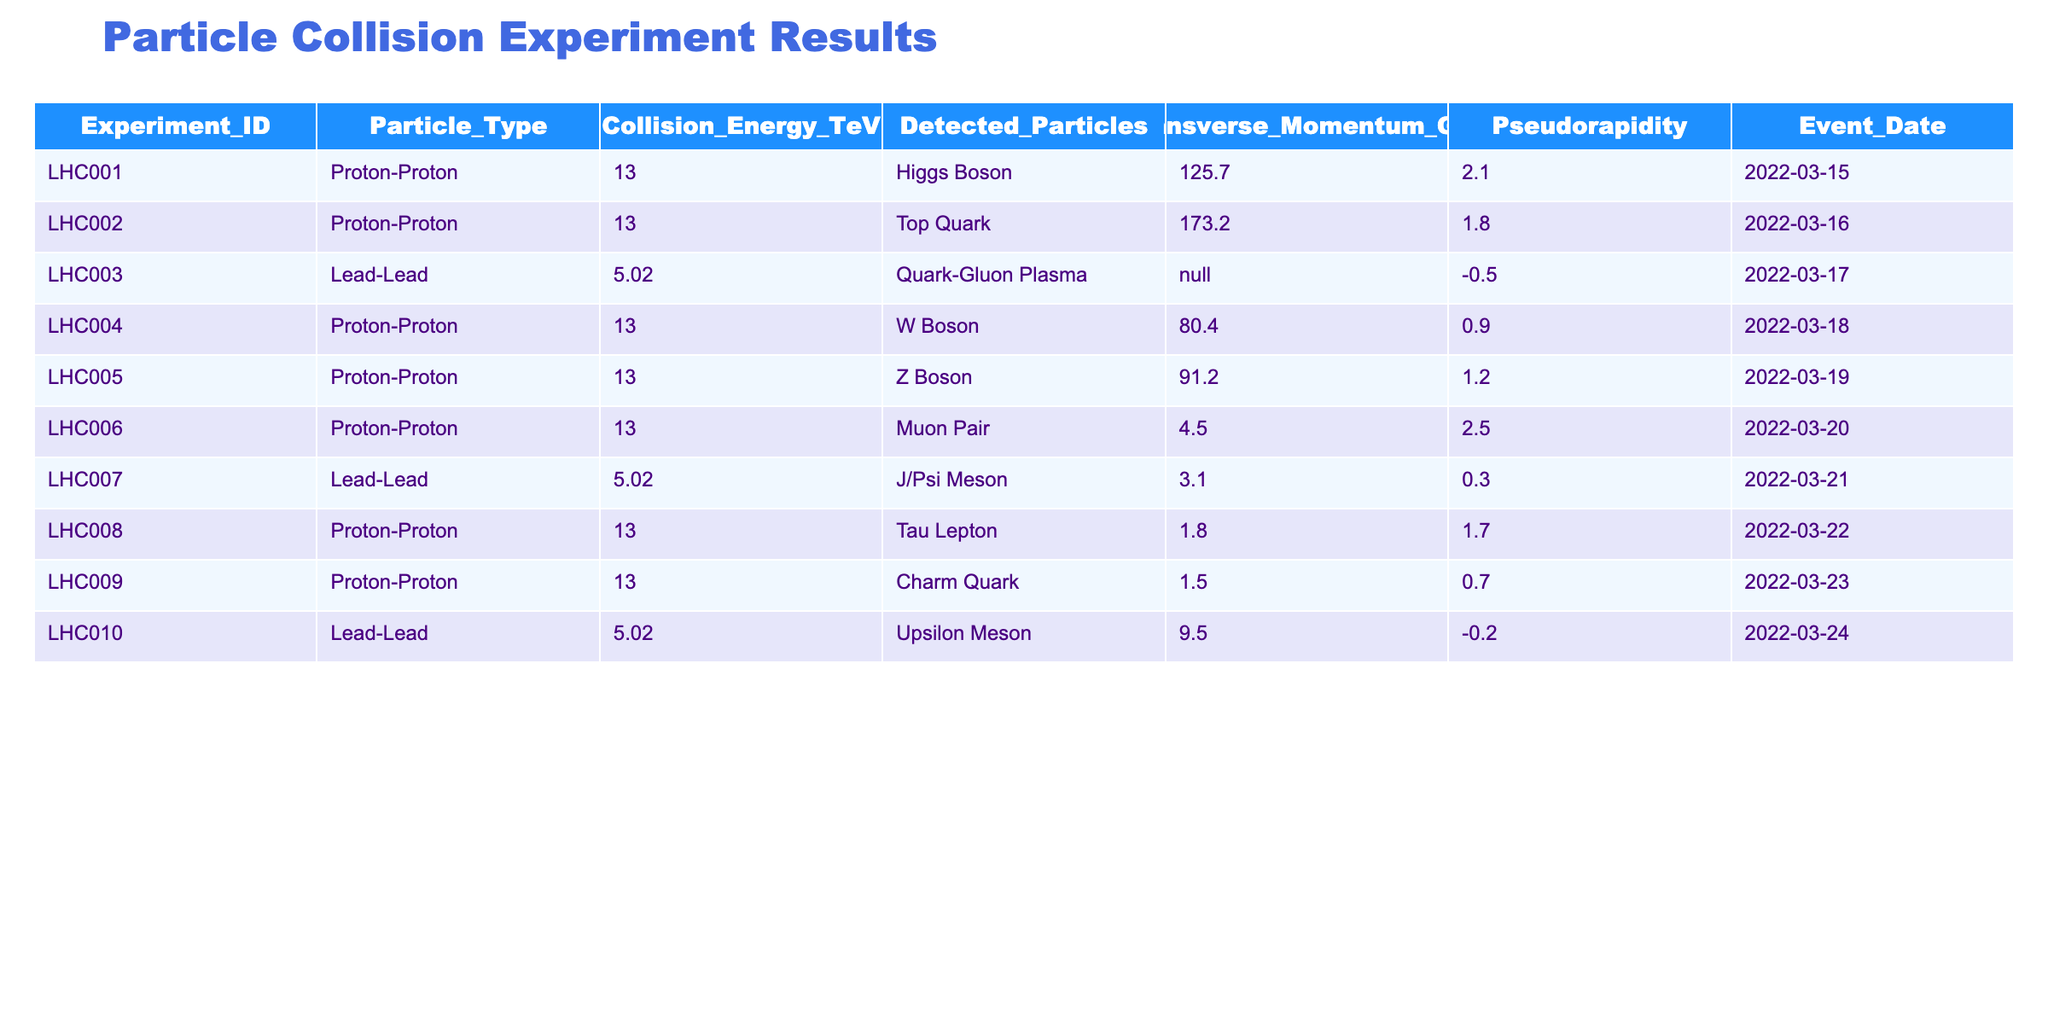What is the Particle Type detected in Experiment LHC005? The table lists the detected particles for each experiment by their Experiment_ID. For LHC005, the detected particle is listed as "Z Boson."
Answer: Z Boson Which Collision Energy has the highest Transverse Momentum? The Transverse Momentum values can be compared from the table. The highest value is 173.2 GeV detected in Experiment LHC002, corresponding to the Top Quark.
Answer: 173.2 GeV Is there any detected particle from the Lead-Lead collisions? By checking the Particle Types listed for Lead-Lead experiments (LHC003, LHC007, LHC010), we can confirm that Quark-Gluon Plasma, J/Psi Meson, and Upsilon Meson are detected. Thus, the answer is yes.
Answer: Yes What was the date of the experiment detecting the W Boson? The table provides event dates corresponding to each experiment. Looking for W Boson in the table, we find that it was detected on 2022-03-18.
Answer: 2022-03-18 What is the average Transverse Momentum of Proton-Proton collisions? First, we identify all the Proton-Proton collision experiments: LHC001, LHC002, LHC004, LHC005, LHC006, LHC008, and LHC009. Their Transverse Momentum values are 125.7, 173.2, 80.4, 91.2, 4.5, 1.8, and 1.5 respectively. The sum is 478.8, and there are 7 values, so the average is 478.8 / 7 ≈ 68.4.
Answer: 68.4 What is the difference in Collision Energy between the Proton-Proton and Lead-Lead experiments? The table indicates the Collision Energy for Proton-Proton is 13 TeV (LHC001, LHC002, LHC004, LHC005, LHC006, LHC008, LHC009) and for Lead-Lead is 5.02 TeV (LHC003, LHC007, LHC010). The difference is calculated as 13 - 5.02 = 7.98 TeV.
Answer: 7.98 TeV Which experiment detected the highest Pseudorapidity, and what was the value? By looking at the Pseudorapidity values in the table, the highest value is 2.5, which corresponds to Experiment LHC006 where the Muon Pair was detected.
Answer: LHC006, 2.5 Are there any experiments on the same date? By examining the Event Dates, we can see that all experiments have unique dates. Hence, there are no duplicate dates for any experiments listed in the table.
Answer: No What is the total number of different Particle Types detected across all experiments? Counting the distinct Particle Types from the table, we have Higgs Boson, Top Quark, Quark-Gluon Plasma, W Boson, Z Boson, Muon Pair, J/Psi Meson, Tau Lepton, Charm Quark, and Upsilon Meson. This results in a total of 10 unique types.
Answer: 10 Which experiment had the lowest Transverse Momentum, and what particle was detected? Among the Transverse Momentum values, the lowest recorded is 1.5 GeV from Experiment LHC009, which detected the Charm Quark.
Answer: LHC009, Charm Quark 